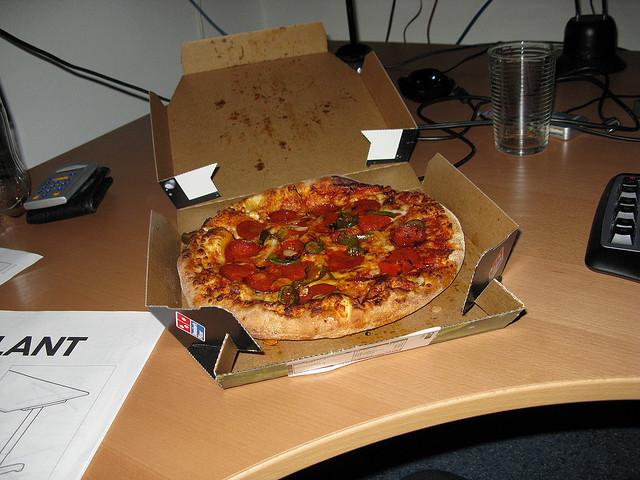What ingredients are on the pizza?
Write a very short answer. Pepperoni. How many cut slices does the pizza have cut?
Write a very short answer. 0. Is the pizza open?
Be succinct. Yes. Is the food on a cutting board?
Keep it brief. No. 